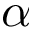Convert formula to latex. <formula><loc_0><loc_0><loc_500><loc_500>\alpha</formula> 